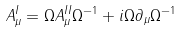<formula> <loc_0><loc_0><loc_500><loc_500>A ^ { I } _ { \mu } = \Omega A ^ { I I } _ { \mu } { \Omega } ^ { - 1 } + i \Omega \partial _ { \mu } { \Omega } ^ { - 1 }</formula> 